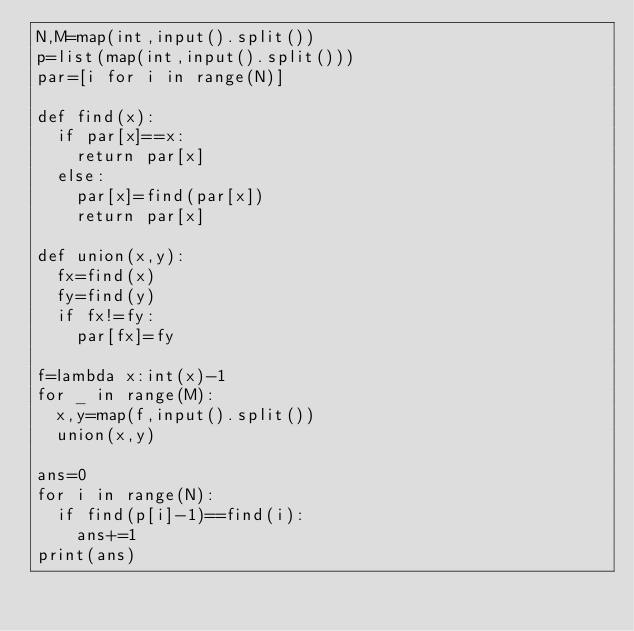<code> <loc_0><loc_0><loc_500><loc_500><_Python_>N,M=map(int,input().split())
p=list(map(int,input().split()))
par=[i for i in range(N)]
 
def find(x):
  if par[x]==x:
    return par[x]
  else:
    par[x]=find(par[x])
    return par[x]

def union(x,y):
  fx=find(x)
  fy=find(y)
  if fx!=fy:
    par[fx]=fy

f=lambda x:int(x)-1
for _ in range(M):
  x,y=map(f,input().split())
  union(x,y)

ans=0
for i in range(N):
  if find(p[i]-1)==find(i):
    ans+=1
print(ans)</code> 